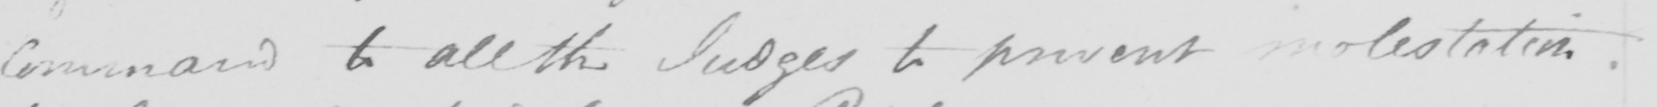Can you tell me what this handwritten text says? command to all the Judges to prevent molestation 